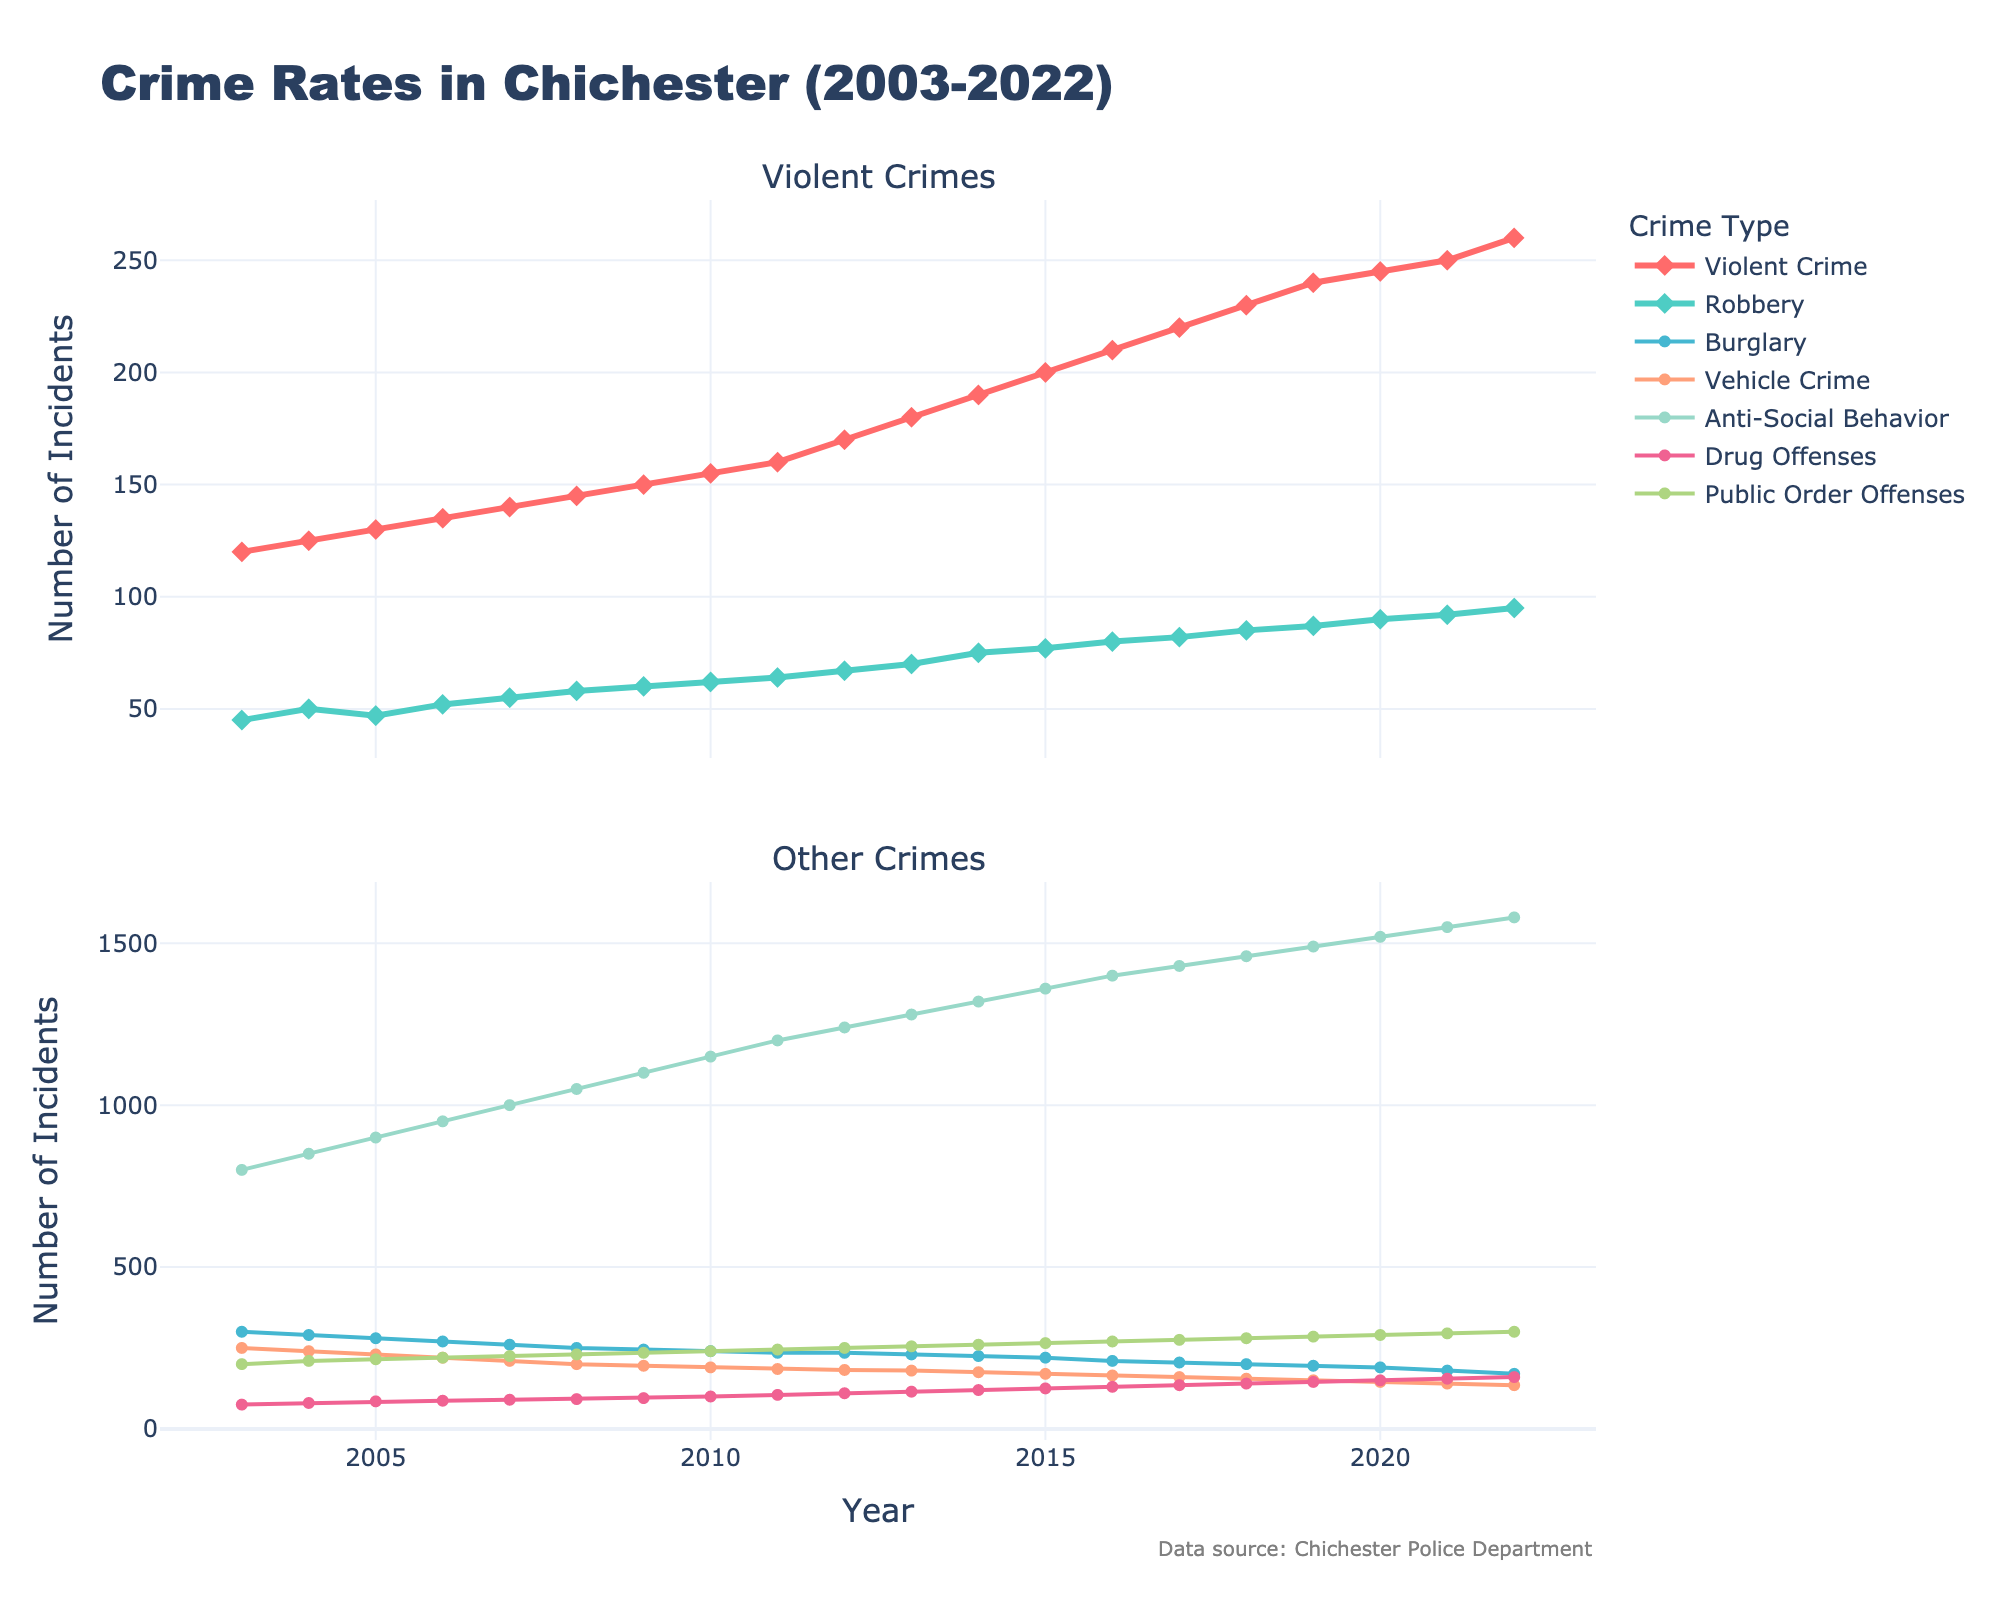What is the title of the plot? The title of the plot is displayed at the top of the figure. It summarizes the content of the plot.
Answer: Crime Rates in Chichester (2003-2022) Which type of crime had the highest number of incidents in 2005? The data points from 2005 on the plot indicate the highest value for Anti-Social Behavior.
Answer: Anti-Social Behavior How has the number of Violent Crimes changed from 2003 to 2022? By observing the line representing Violent Crime from 2003 to 2022, we can see a steady increase over the years.
Answer: Increase Which two crimes had the closest number of incidents in 2018? In 2018, by comparing the values of each crime, Robbery and Public Order Offenses had similar numbers of incidents.
Answer: Robbery and Public Order Offenses How many types of crimes are being tracked in the plot? Counting the different colored lines and markers representing different crimes, there are seven types of crimes tracked.
Answer: Seven What is the difference in the number of Burglary incidents between 2009 and 2022? In 2009, there were 245 incidents of Burglary and, in 2022, there were 170. The difference is 245 - 170.
Answer: 75 Which crime showed the most significant increase in incidents from 2003 to 2022? By comparing the slopes of all the crime lines from 2003 to 2022, Anti-Social Behavior shows the most significant increase.
Answer: Anti-Social Behavior What is the overall trend for Vehicle Crime over the analyzed period? The line representing Vehicle Crime shows a downward trend from 2003 to 2022.
Answer: Decrease Which year had the highest number of Drug Offenses? By identifying the peak point in the line representing Drug Offenses, the highest number occurred in 2022.
Answer: 2022 What is the average number of Violent Crimes from 2003 to 2022? Sum the number of Violent Crimes from each year and divide by 20 (number of years). The calculation is (120 + 125 + 130 + 135 + 140 + 145 + 150 + 155 + 160 + 170 + 180 + 190+ 200 + 210 + 220 + 230 + 240 + 245 + 250 + 260)/20 = 185.25
Answer: 185.25 